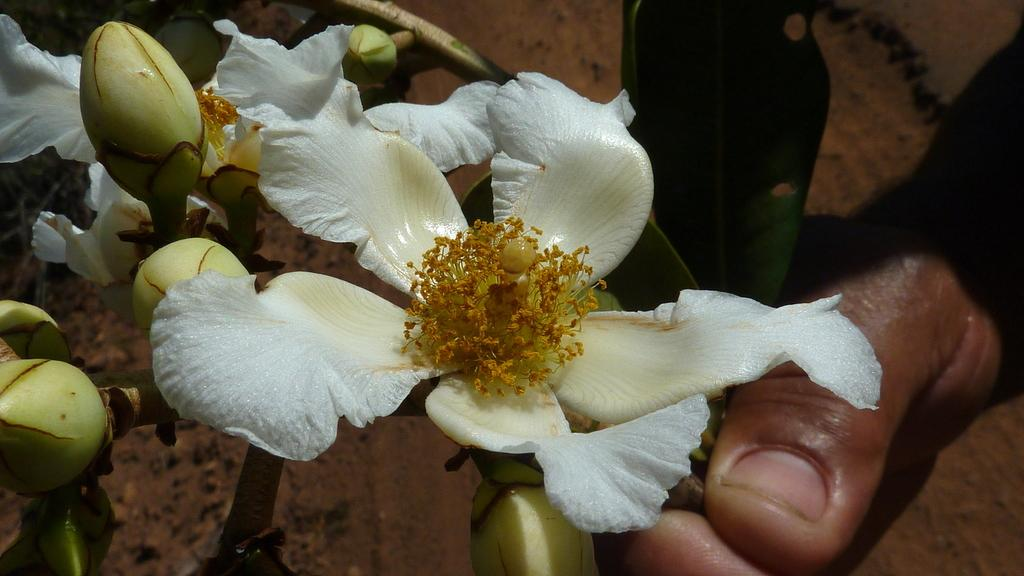What is in the foreground of the picture? There are flowers, buds, and stems in the foreground of the picture. Can you describe the person's hand in the foreground of the picture? A person's hand is visible in the foreground of the picture. What is the background of the picture? The background appears to be a floor. What else can be seen in the background of the picture? There are leaves in the background of the picture. What type of comb is being used to groom the kitty in the picture? There is no kitty or comb present in the picture. Can you describe the texture of the kitty's fur in the picture? There is no kitty present in the picture, so we cannot describe its fur texture. 